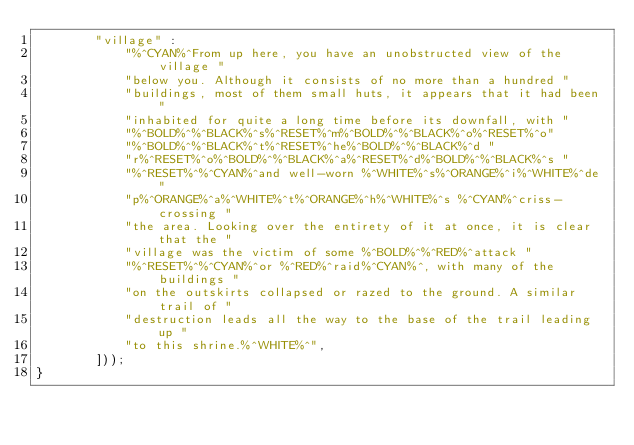Convert code to text. <code><loc_0><loc_0><loc_500><loc_500><_C_>        "village" :
            "%^CYAN%^From up here, you have an unobstructed view of the village "
            "below you. Although it consists of no more than a hundred "
            "buildings, most of them small huts, it appears that it had been "
            "inhabited for quite a long time before its downfall, with "
            "%^BOLD%^%^BLACK%^s%^RESET%^m%^BOLD%^%^BLACK%^o%^RESET%^o"
            "%^BOLD%^%^BLACK%^t%^RESET%^he%^BOLD%^%^BLACK%^d "
            "r%^RESET%^o%^BOLD%^%^BLACK%^a%^RESET%^d%^BOLD%^%^BLACK%^s "
            "%^RESET%^%^CYAN%^and well-worn %^WHITE%^s%^ORANGE%^i%^WHITE%^de "
            "p%^ORANGE%^a%^WHITE%^t%^ORANGE%^h%^WHITE%^s %^CYAN%^criss-crossing "
            "the area. Looking over the entirety of it at once, it is clear that the "
            "village was the victim of some %^BOLD%^%^RED%^attack "
            "%^RESET%^%^CYAN%^or %^RED%^raid%^CYAN%^, with many of the buildings "
            "on the outskirts collapsed or razed to the ground. A similar trail of "
            "destruction leads all the way to the base of the trail leading up "
            "to this shrine.%^WHITE%^",
        ]));
}
</code> 